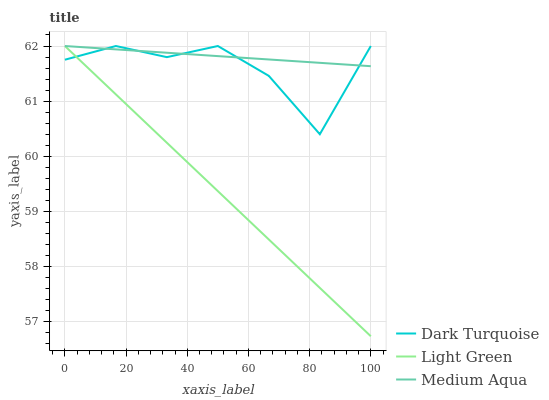Does Light Green have the minimum area under the curve?
Answer yes or no. Yes. Does Medium Aqua have the maximum area under the curve?
Answer yes or no. Yes. Does Medium Aqua have the minimum area under the curve?
Answer yes or no. No. Does Light Green have the maximum area under the curve?
Answer yes or no. No. Is Medium Aqua the smoothest?
Answer yes or no. Yes. Is Dark Turquoise the roughest?
Answer yes or no. Yes. Is Light Green the smoothest?
Answer yes or no. No. Is Light Green the roughest?
Answer yes or no. No. Does Medium Aqua have the lowest value?
Answer yes or no. No. 